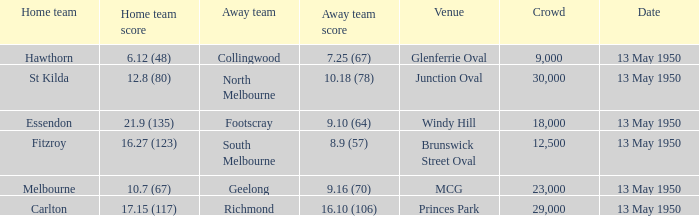What was the away team's score when Fitzroy's score was 16.27 (123) on May 13, 1950. 8.9 (57). 